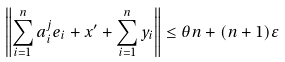Convert formula to latex. <formula><loc_0><loc_0><loc_500><loc_500>\left \| \sum _ { i = 1 } ^ { n } a ^ { j } _ { i } e _ { i } + x ^ { \prime } + \sum _ { i = 1 } ^ { n } y _ { i } \right \| \leq \theta n + ( { n } + 1 ) \varepsilon</formula> 